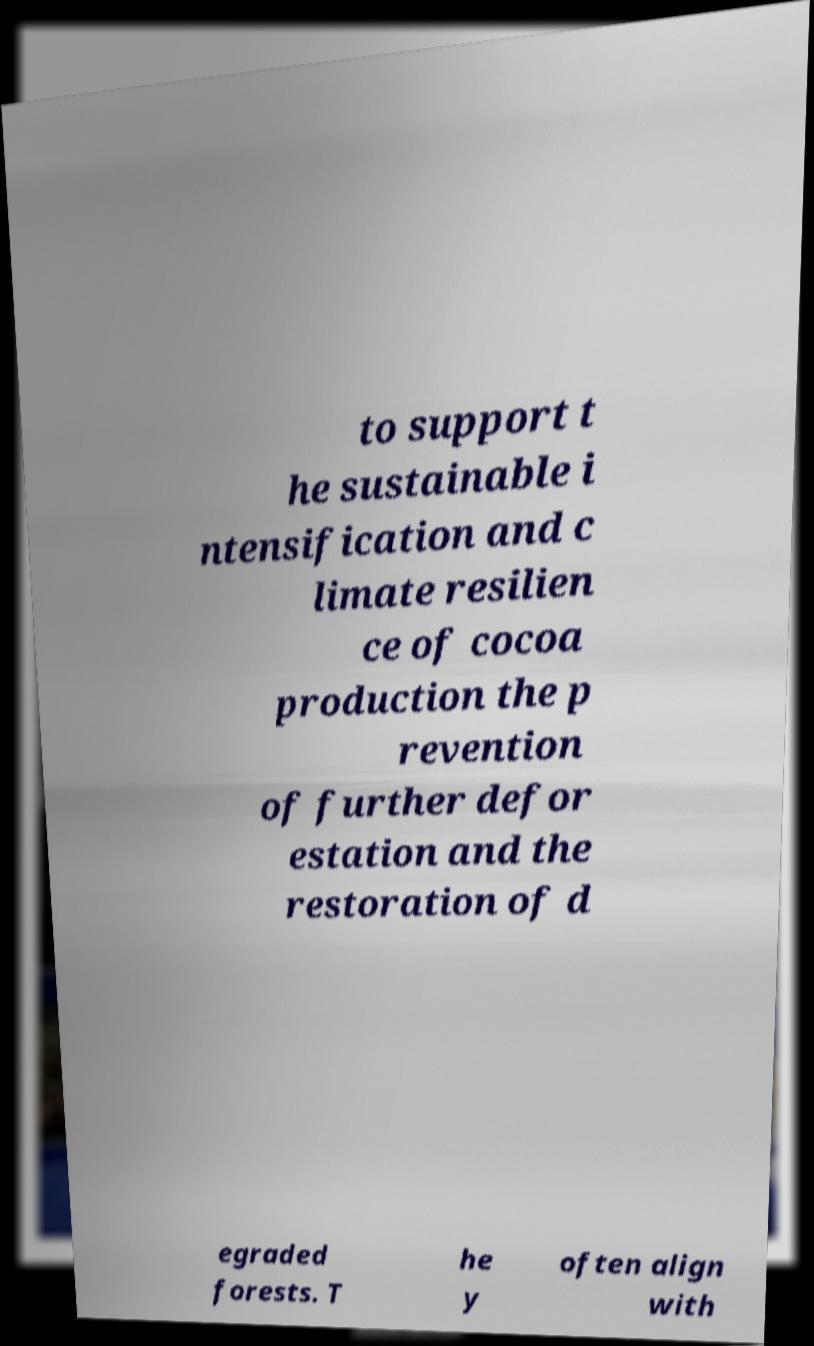Can you read and provide the text displayed in the image?This photo seems to have some interesting text. Can you extract and type it out for me? to support t he sustainable i ntensification and c limate resilien ce of cocoa production the p revention of further defor estation and the restoration of d egraded forests. T he y often align with 